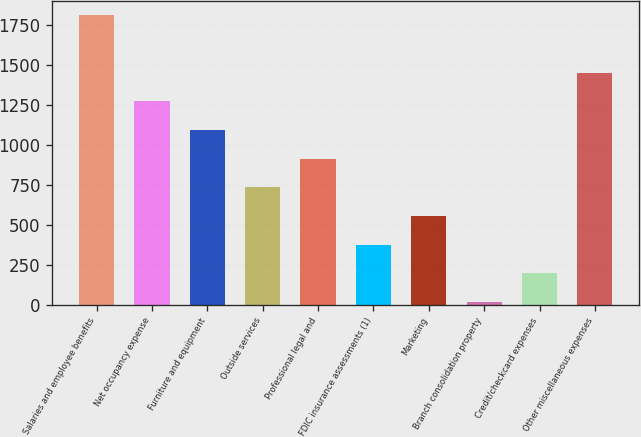Convert chart to OTSL. <chart><loc_0><loc_0><loc_500><loc_500><bar_chart><fcel>Salaries and employee benefits<fcel>Net occupancy expense<fcel>Furniture and equipment<fcel>Outside services<fcel>Professional legal and<fcel>FDIC insurance assessments (1)<fcel>Marketing<fcel>Branch consolidation property<fcel>Credit/checkcard expenses<fcel>Other miscellaneous expenses<nl><fcel>1810<fcel>1271.8<fcel>1092.4<fcel>733.6<fcel>913<fcel>374.8<fcel>554.2<fcel>16<fcel>195.4<fcel>1451.2<nl></chart> 